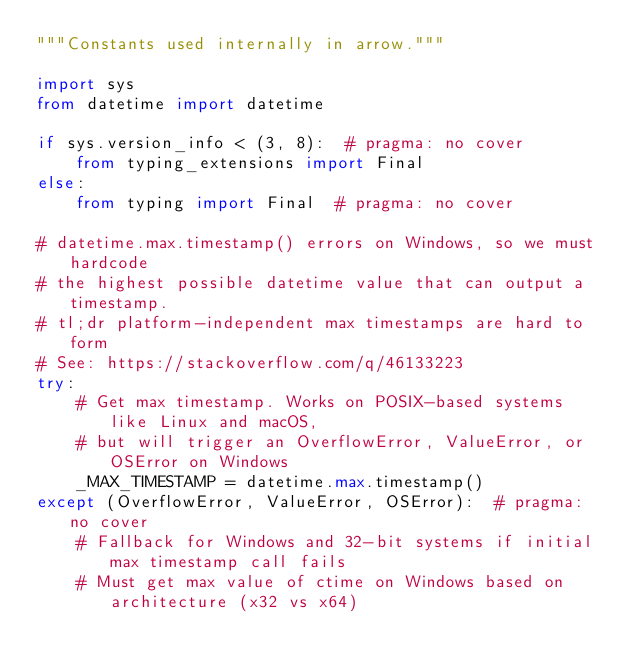Convert code to text. <code><loc_0><loc_0><loc_500><loc_500><_Python_>"""Constants used internally in arrow."""

import sys
from datetime import datetime

if sys.version_info < (3, 8):  # pragma: no cover
    from typing_extensions import Final
else:
    from typing import Final  # pragma: no cover

# datetime.max.timestamp() errors on Windows, so we must hardcode
# the highest possible datetime value that can output a timestamp.
# tl;dr platform-independent max timestamps are hard to form
# See: https://stackoverflow.com/q/46133223
try:
    # Get max timestamp. Works on POSIX-based systems like Linux and macOS,
    # but will trigger an OverflowError, ValueError, or OSError on Windows
    _MAX_TIMESTAMP = datetime.max.timestamp()
except (OverflowError, ValueError, OSError):  # pragma: no cover
    # Fallback for Windows and 32-bit systems if initial max timestamp call fails
    # Must get max value of ctime on Windows based on architecture (x32 vs x64)</code> 